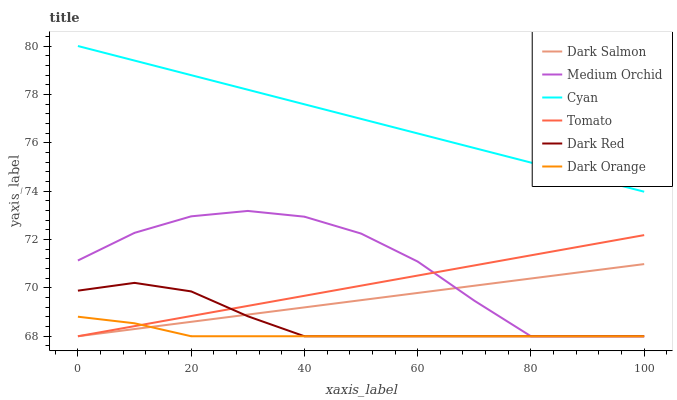Does Dark Orange have the minimum area under the curve?
Answer yes or no. Yes. Does Cyan have the maximum area under the curve?
Answer yes or no. Yes. Does Dark Red have the minimum area under the curve?
Answer yes or no. No. Does Dark Red have the maximum area under the curve?
Answer yes or no. No. Is Tomato the smoothest?
Answer yes or no. Yes. Is Medium Orchid the roughest?
Answer yes or no. Yes. Is Dark Orange the smoothest?
Answer yes or no. No. Is Dark Orange the roughest?
Answer yes or no. No. Does Tomato have the lowest value?
Answer yes or no. Yes. Does Cyan have the lowest value?
Answer yes or no. No. Does Cyan have the highest value?
Answer yes or no. Yes. Does Dark Red have the highest value?
Answer yes or no. No. Is Dark Red less than Cyan?
Answer yes or no. Yes. Is Cyan greater than Dark Orange?
Answer yes or no. Yes. Does Tomato intersect Dark Red?
Answer yes or no. Yes. Is Tomato less than Dark Red?
Answer yes or no. No. Is Tomato greater than Dark Red?
Answer yes or no. No. Does Dark Red intersect Cyan?
Answer yes or no. No. 